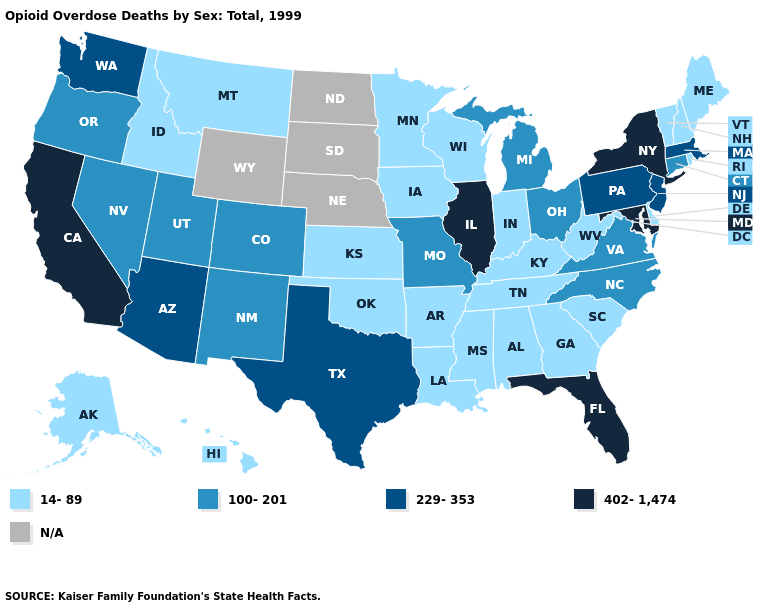What is the value of Hawaii?
Write a very short answer. 14-89. Is the legend a continuous bar?
Short answer required. No. Among the states that border Indiana , does Kentucky have the lowest value?
Short answer required. Yes. Is the legend a continuous bar?
Be succinct. No. Does Connecticut have the lowest value in the Northeast?
Give a very brief answer. No. Name the states that have a value in the range N/A?
Give a very brief answer. Nebraska, North Dakota, South Dakota, Wyoming. Which states have the highest value in the USA?
Give a very brief answer. California, Florida, Illinois, Maryland, New York. Does the first symbol in the legend represent the smallest category?
Write a very short answer. Yes. What is the value of Maryland?
Write a very short answer. 402-1,474. Does the map have missing data?
Quick response, please. Yes. What is the value of Texas?
Answer briefly. 229-353. Name the states that have a value in the range 14-89?
Concise answer only. Alabama, Alaska, Arkansas, Delaware, Georgia, Hawaii, Idaho, Indiana, Iowa, Kansas, Kentucky, Louisiana, Maine, Minnesota, Mississippi, Montana, New Hampshire, Oklahoma, Rhode Island, South Carolina, Tennessee, Vermont, West Virginia, Wisconsin. What is the value of South Carolina?
Quick response, please. 14-89. Which states have the lowest value in the USA?
Quick response, please. Alabama, Alaska, Arkansas, Delaware, Georgia, Hawaii, Idaho, Indiana, Iowa, Kansas, Kentucky, Louisiana, Maine, Minnesota, Mississippi, Montana, New Hampshire, Oklahoma, Rhode Island, South Carolina, Tennessee, Vermont, West Virginia, Wisconsin. 